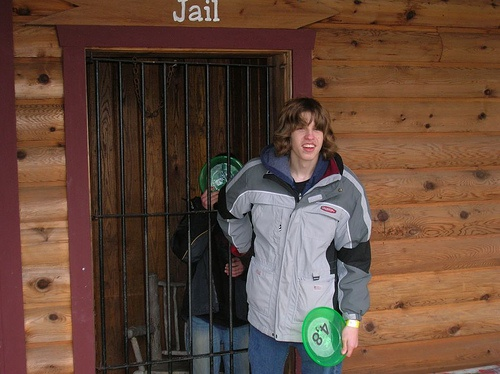Describe the objects in this image and their specific colors. I can see people in black, darkgray, and gray tones, people in black, gray, blue, and darkblue tones, chair in black and gray tones, frisbee in black, green, aquamarine, and teal tones, and frisbee in black, teal, and darkgreen tones in this image. 